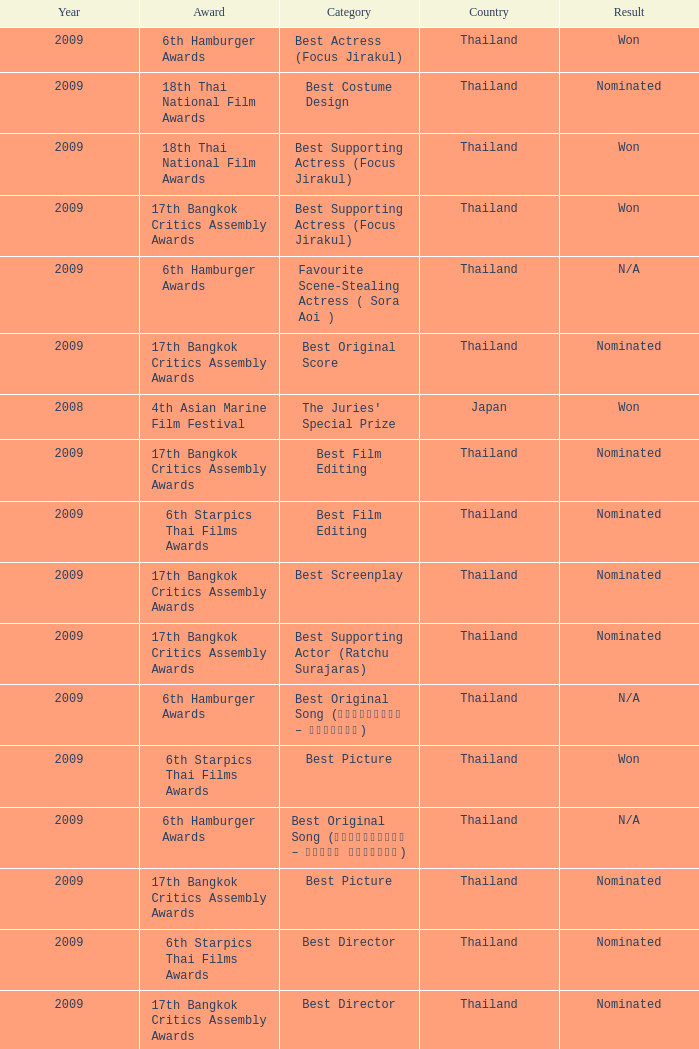Which Country has a Result of nominated, an Award of 17th bangkok critics assembly awards, and a Category of best screenplay? Thailand. 